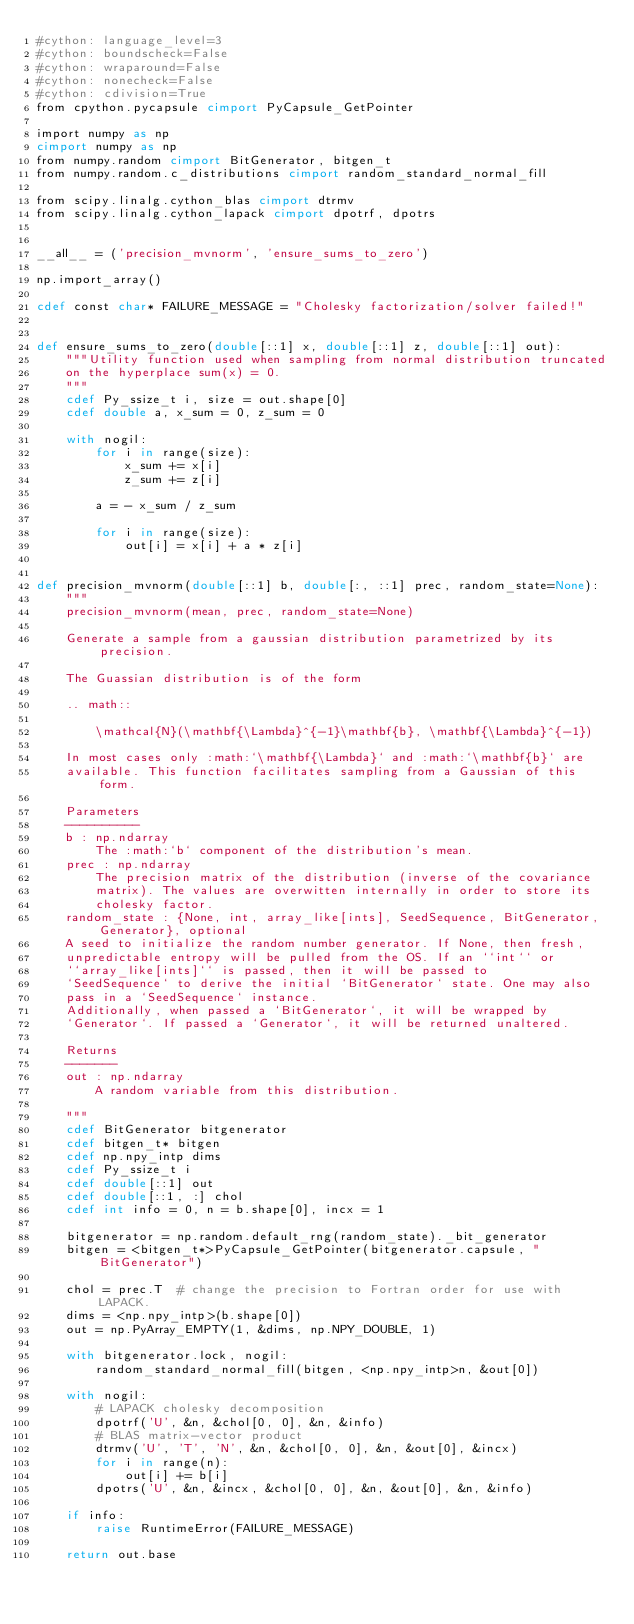Convert code to text. <code><loc_0><loc_0><loc_500><loc_500><_Cython_>#cython: language_level=3
#cython: boundscheck=False
#cython: wraparound=False
#cython: nonecheck=False
#cython: cdivision=True
from cpython.pycapsule cimport PyCapsule_GetPointer

import numpy as np
cimport numpy as np
from numpy.random cimport BitGenerator, bitgen_t
from numpy.random.c_distributions cimport random_standard_normal_fill

from scipy.linalg.cython_blas cimport dtrmv
from scipy.linalg.cython_lapack cimport dpotrf, dpotrs


__all__ = ('precision_mvnorm', 'ensure_sums_to_zero')

np.import_array()

cdef const char* FAILURE_MESSAGE = "Cholesky factorization/solver failed!"


def ensure_sums_to_zero(double[::1] x, double[::1] z, double[::1] out):
    """Utility function used when sampling from normal distribution truncated
    on the hyperplace sum(x) = 0.
    """
    cdef Py_ssize_t i, size = out.shape[0]
    cdef double a, x_sum = 0, z_sum = 0

    with nogil:
        for i in range(size):
            x_sum += x[i]
            z_sum += z[i]

        a = - x_sum / z_sum

        for i in range(size):
            out[i] = x[i] + a * z[i]


def precision_mvnorm(double[::1] b, double[:, ::1] prec, random_state=None):
    """
    precision_mvnorm(mean, prec, random_state=None)

    Generate a sample from a gaussian distribution parametrized by its precision.

    The Guassian distribution is of the form

    .. math::

        \mathcal{N}(\mathbf{\Lambda}^{-1}\mathbf{b}, \mathbf{\Lambda}^{-1})

    In most cases only :math:`\mathbf{\Lambda}` and :math:`\mathbf{b}` are
    available. This function facilitates sampling from a Gaussian of this form.

    Parameters
    ----------
    b : np.ndarray
        The :math:`b` component of the distribution's mean.
    prec : np.ndarray
        The precision matrix of the distribution (inverse of the covariance
        matrix). The values are overwitten internally in order to store its
        cholesky factor.
    random_state : {None, int, array_like[ints], SeedSequence, BitGenerator, Generator}, optional
    A seed to initialize the random number generator. If None, then fresh,
    unpredictable entropy will be pulled from the OS. If an ``int`` or
    ``array_like[ints]`` is passed, then it will be passed to
    `SeedSequence` to derive the initial `BitGenerator` state. One may also
    pass in a `SeedSequence` instance.
    Additionally, when passed a `BitGenerator`, it will be wrapped by
    `Generator`. If passed a `Generator`, it will be returned unaltered.

    Returns
    -------
    out : np.ndarray
        A random variable from this distribution.

    """
    cdef BitGenerator bitgenerator
    cdef bitgen_t* bitgen
    cdef np.npy_intp dims
    cdef Py_ssize_t i
    cdef double[::1] out
    cdef double[::1, :] chol
    cdef int info = 0, n = b.shape[0], incx = 1

    bitgenerator = np.random.default_rng(random_state)._bit_generator
    bitgen = <bitgen_t*>PyCapsule_GetPointer(bitgenerator.capsule, "BitGenerator")

    chol = prec.T  # change the precision to Fortran order for use with LAPACK.
    dims = <np.npy_intp>(b.shape[0])
    out = np.PyArray_EMPTY(1, &dims, np.NPY_DOUBLE, 1)

    with bitgenerator.lock, nogil:
        random_standard_normal_fill(bitgen, <np.npy_intp>n, &out[0])

    with nogil:
        # LAPACK cholesky decomposition
        dpotrf('U', &n, &chol[0, 0], &n, &info)
        # BLAS matrix-vector product
        dtrmv('U', 'T', 'N', &n, &chol[0, 0], &n, &out[0], &incx)
        for i in range(n):
            out[i] += b[i]
        dpotrs('U', &n, &incx, &chol[0, 0], &n, &out[0], &n, &info)

    if info:
        raise RuntimeError(FAILURE_MESSAGE)

    return out.base
</code> 